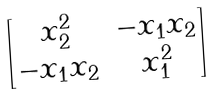Convert formula to latex. <formula><loc_0><loc_0><loc_500><loc_500>\begin{bmatrix} x _ { 2 } ^ { 2 } & - x _ { 1 } x _ { 2 } \\ - x _ { 1 } x _ { 2 } & x _ { 1 } ^ { 2 } \end{bmatrix}</formula> 